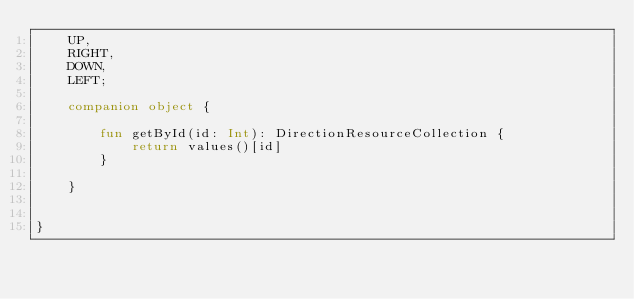<code> <loc_0><loc_0><loc_500><loc_500><_Kotlin_>    UP,
    RIGHT,
    DOWN,
    LEFT;

    companion object {

        fun getById(id: Int): DirectionResourceCollection {
            return values()[id]
        }

    }


}
</code> 